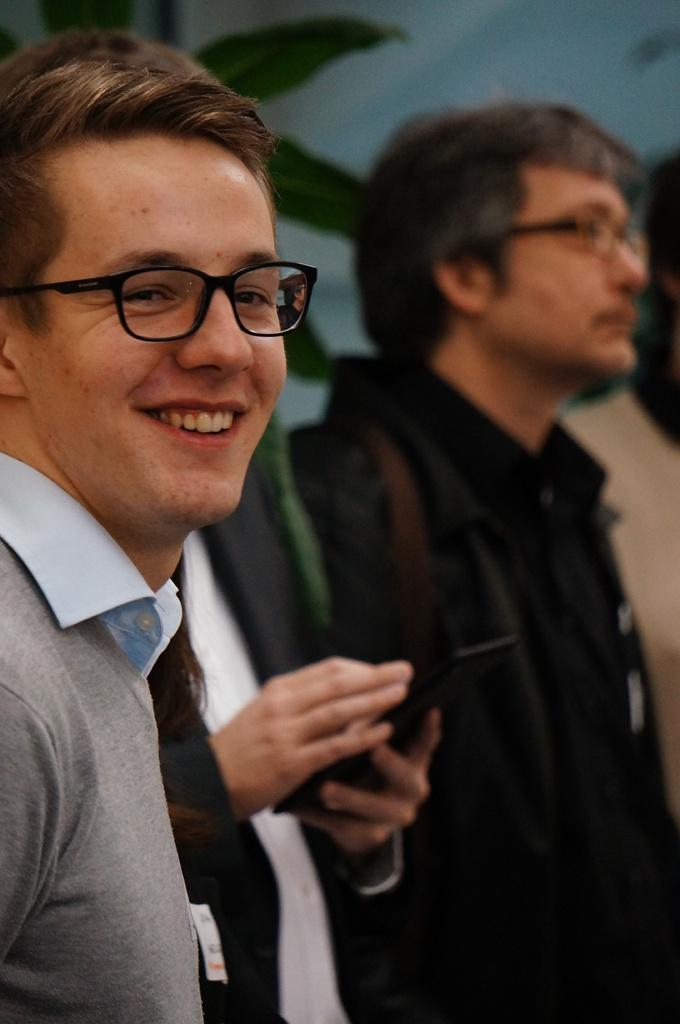How many people are in the image? There are two people in the image. What is the person in front wearing? The person in front is wearing a gray shirt. What is the person at the back wearing? The person at the back is wearing a black dress. What type of vegetation can be seen in the image? There are green leaves visible in the image. Where is the throne located in the image? There is no throne present in the image. How many legs does the person in the gray shirt have? The person in the gray shirt has two legs, as humans typically have. 